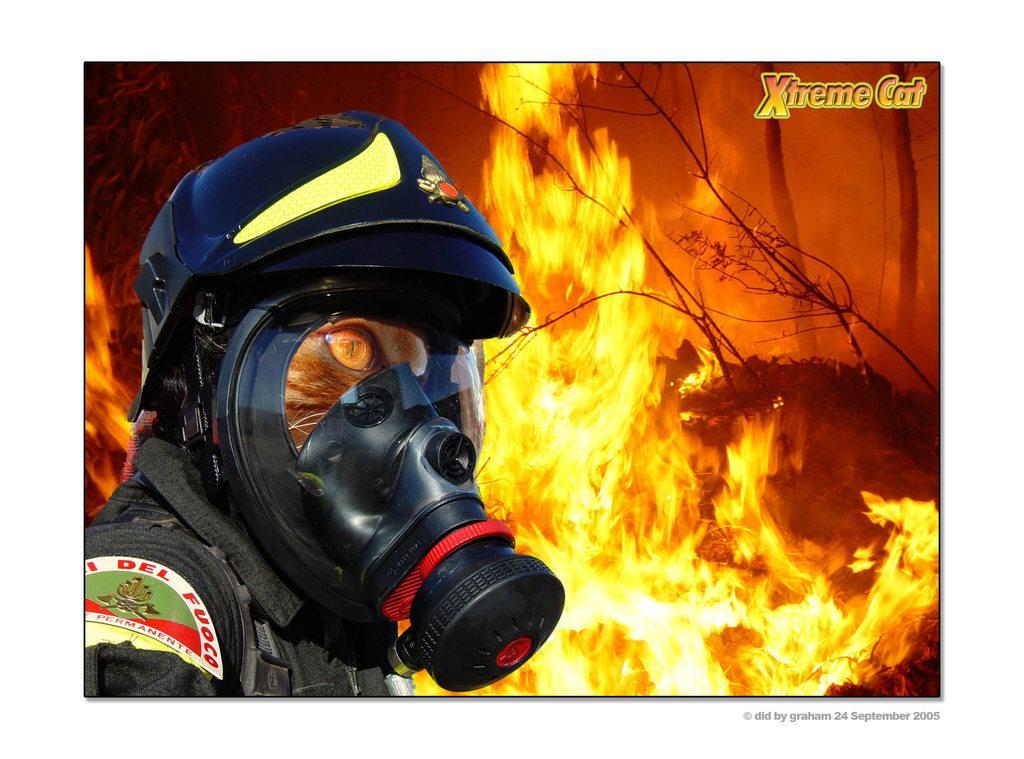How would you summarize this image in a sentence or two? This is an animated picture. In this picture there is an animal wearing mask helmet and coat. In the center of the picture we can see trees burning and there are flames. At the top there is text. 